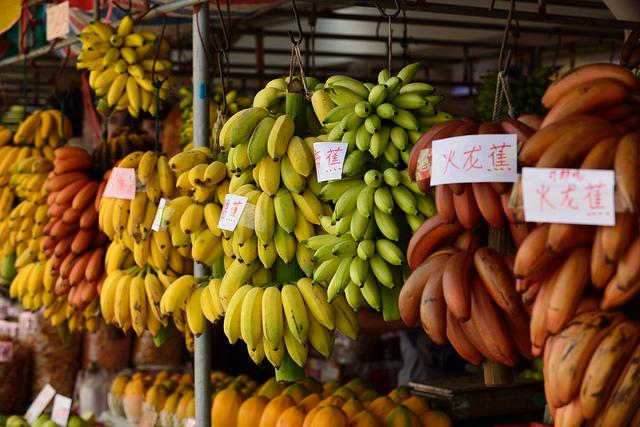What color string are the bananas hanging on?
Quick response, please. Brown. Are there any melons for sale?
Short answer required. No. How much do the bananas cost?
Quick response, please. Unknown. What is the orange food?
Keep it brief. Squash. Are some of the bananas bruised?
Be succinct. Yes. Is this in America?
Be succinct. No. Is the fruit ripe?
Concise answer only. Yes. I can recognize four fruits?
Concise answer only. Yes. What types of fruit are in this picture?
Give a very brief answer. Bananas. Which fruit could be plantains?
Answer briefly. Far right. What material is the price signs made of?
Answer briefly. Paper. Does this stand sell fried foods?
Keep it brief. No. What kind of food is that?
Write a very short answer. Banana. What color is the fruit being sold that is not ripe?
Short answer required. Green. 